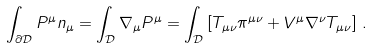Convert formula to latex. <formula><loc_0><loc_0><loc_500><loc_500>\int _ { \partial \mathcal { D } } P ^ { \mu } n _ { \mu } = \int _ { \mathcal { D } } \nabla _ { \mu } P ^ { \mu } = \int _ { \mathcal { D } } \left [ T _ { \mu \nu } \pi ^ { \mu \nu } + V ^ { \mu } \nabla ^ { \nu } T _ { \mu \nu } \right ] \, .</formula> 